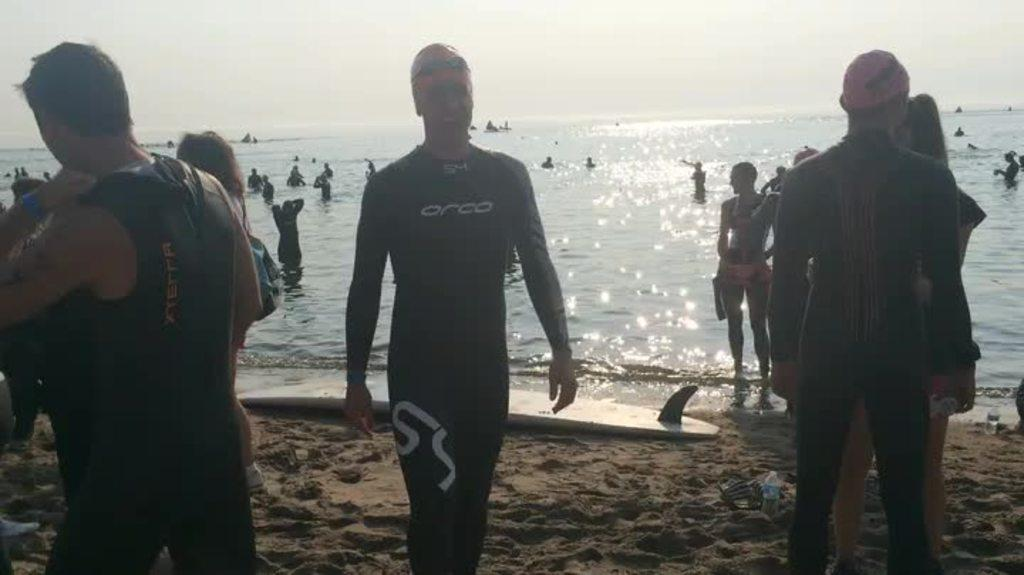What is the main setting of the image? The main setting of the image is a beach area. Where are the persons located in the image? The persons are standing in the beach area. What can be seen in the background of the image? There is a sea in the background of the image. What is visible at the top of the image? The sky is visible at the top of the image. What type of jam is being spread on the sand in the image? There is no jam present in the image; it is a beach area with persons standing near the sea. 